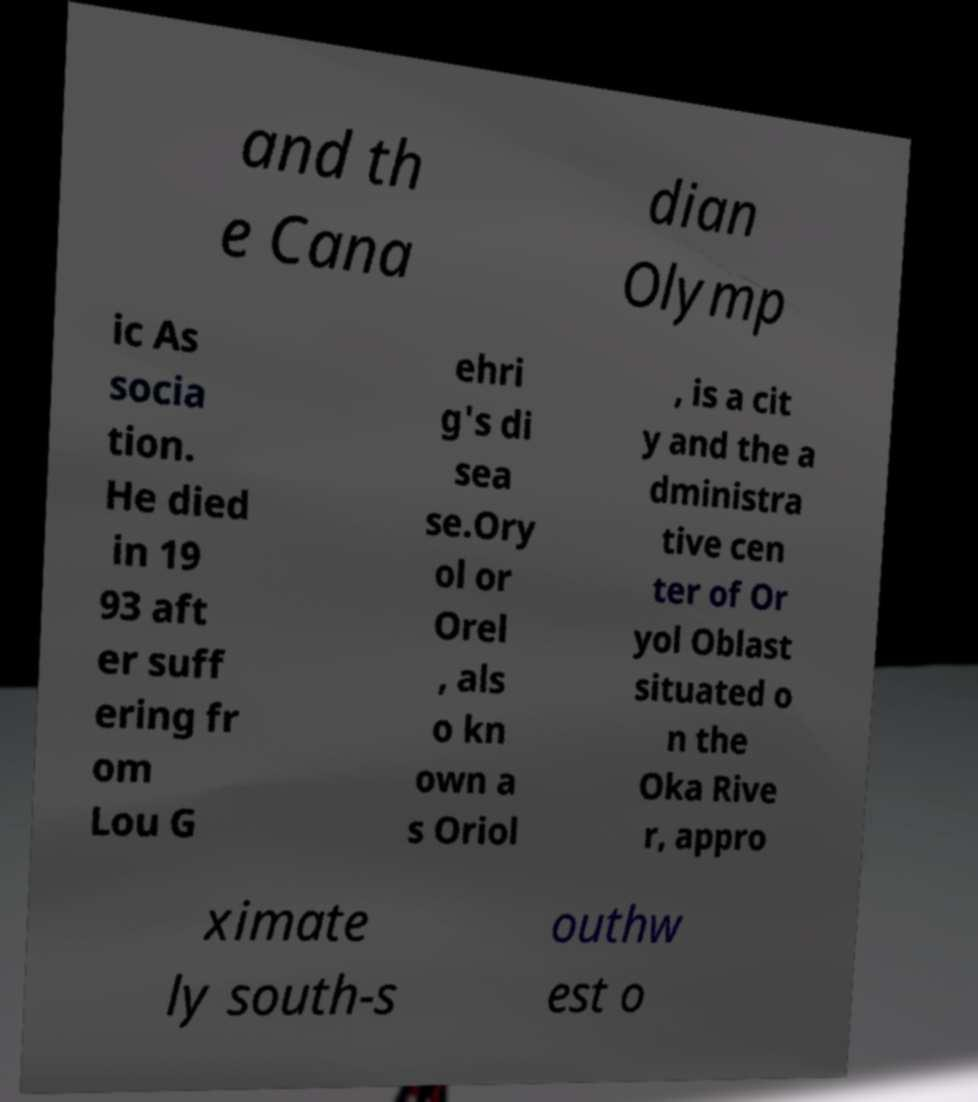There's text embedded in this image that I need extracted. Can you transcribe it verbatim? and th e Cana dian Olymp ic As socia tion. He died in 19 93 aft er suff ering fr om Lou G ehri g's di sea se.Ory ol or Orel , als o kn own a s Oriol , is a cit y and the a dministra tive cen ter of Or yol Oblast situated o n the Oka Rive r, appro ximate ly south-s outhw est o 